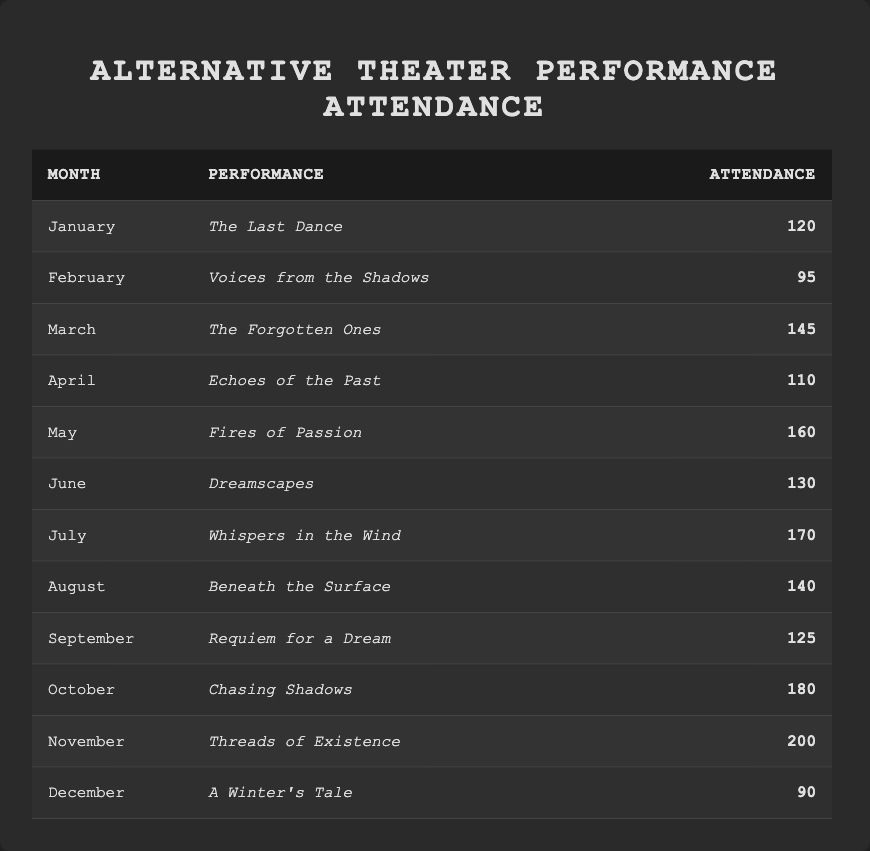What was the performance with the highest attendance? Looking at the table, "Threads of Existence" in November has the highest attendance number at 200.
Answer: Threads of Existence In what month did "Chasing Shadows" take place? "Chasing Shadows" is listed under October.
Answer: October What is the total attendance for the performances in the first half of the year (January to June)? Sum the attendances for January (120), February (95), March (145), April (110), May (160), and June (130): 120 + 95 + 145 + 110 + 160 + 130 = 960.
Answer: 960 Which month had the lowest attendance, and what was the attendance number? December had the lowest attendance number, which is 90.
Answer: December, 90 What is the average attendance for the performances from July to December? Add the attendances for July (170), August (140), September (125), October (180), November (200), and December (90): 170 + 140 + 125 + 180 + 200 + 90 = 1005. There are 6 months, so the average is 1005/6 = 167.5.
Answer: 167.5 Did attendance increase from May to June? The attendance in May was 160, and in June, it decreased to 130, so attendance did not increase.
Answer: No How many performances had an attendance of over 150? Looking through the table, "Fires of Passion," "Whispers in the Wind," "Chasing Shadows," and "Threads of Existence" had attendances over 150 (160, 170, 180, and 200 respectively), which totals 4 performances.
Answer: 4 What was the difference in attendance between the highest and lowest months? The highest attendance was 200 in November for "Threads of Existence," and the lowest was 90 in December for "A Winter's Tale." Thus, the difference is 200 - 90 = 110.
Answer: 110 Which performance had an attendance closest to 130? The performance "Dreamscapes" in June had an attendance of 130, which is exactly the same.
Answer: Dreamscapes What percentage of total attendance does the performance in October represent? Total attendance is 1395 (sum all attendance numbers). October's attendance is 180. To find the percentage, divide October's attendance by total: (180/1395) * 100 ≈ 12.87%.
Answer: 12.87% 